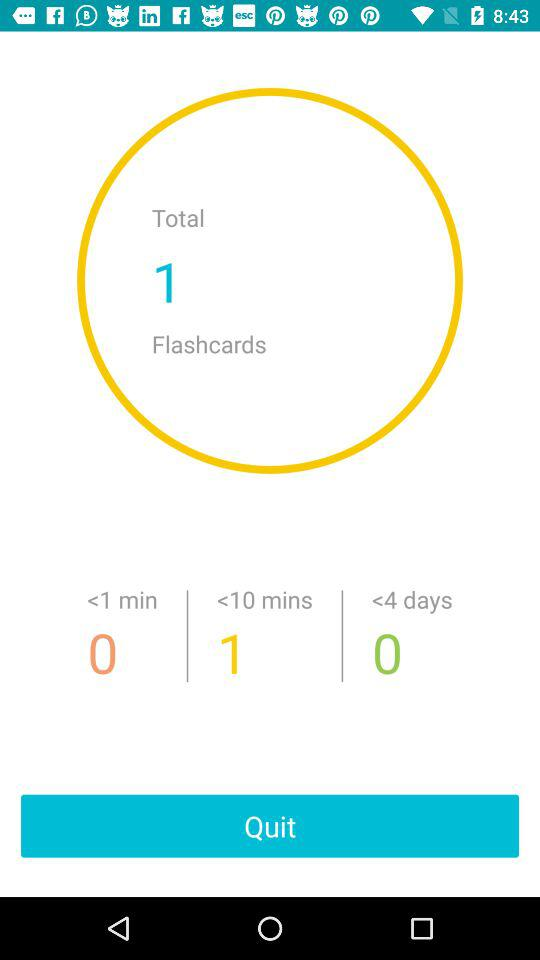How many more items have a time of less than 10 minutes than items with a time of less than 4 days?
Answer the question using a single word or phrase. 1 